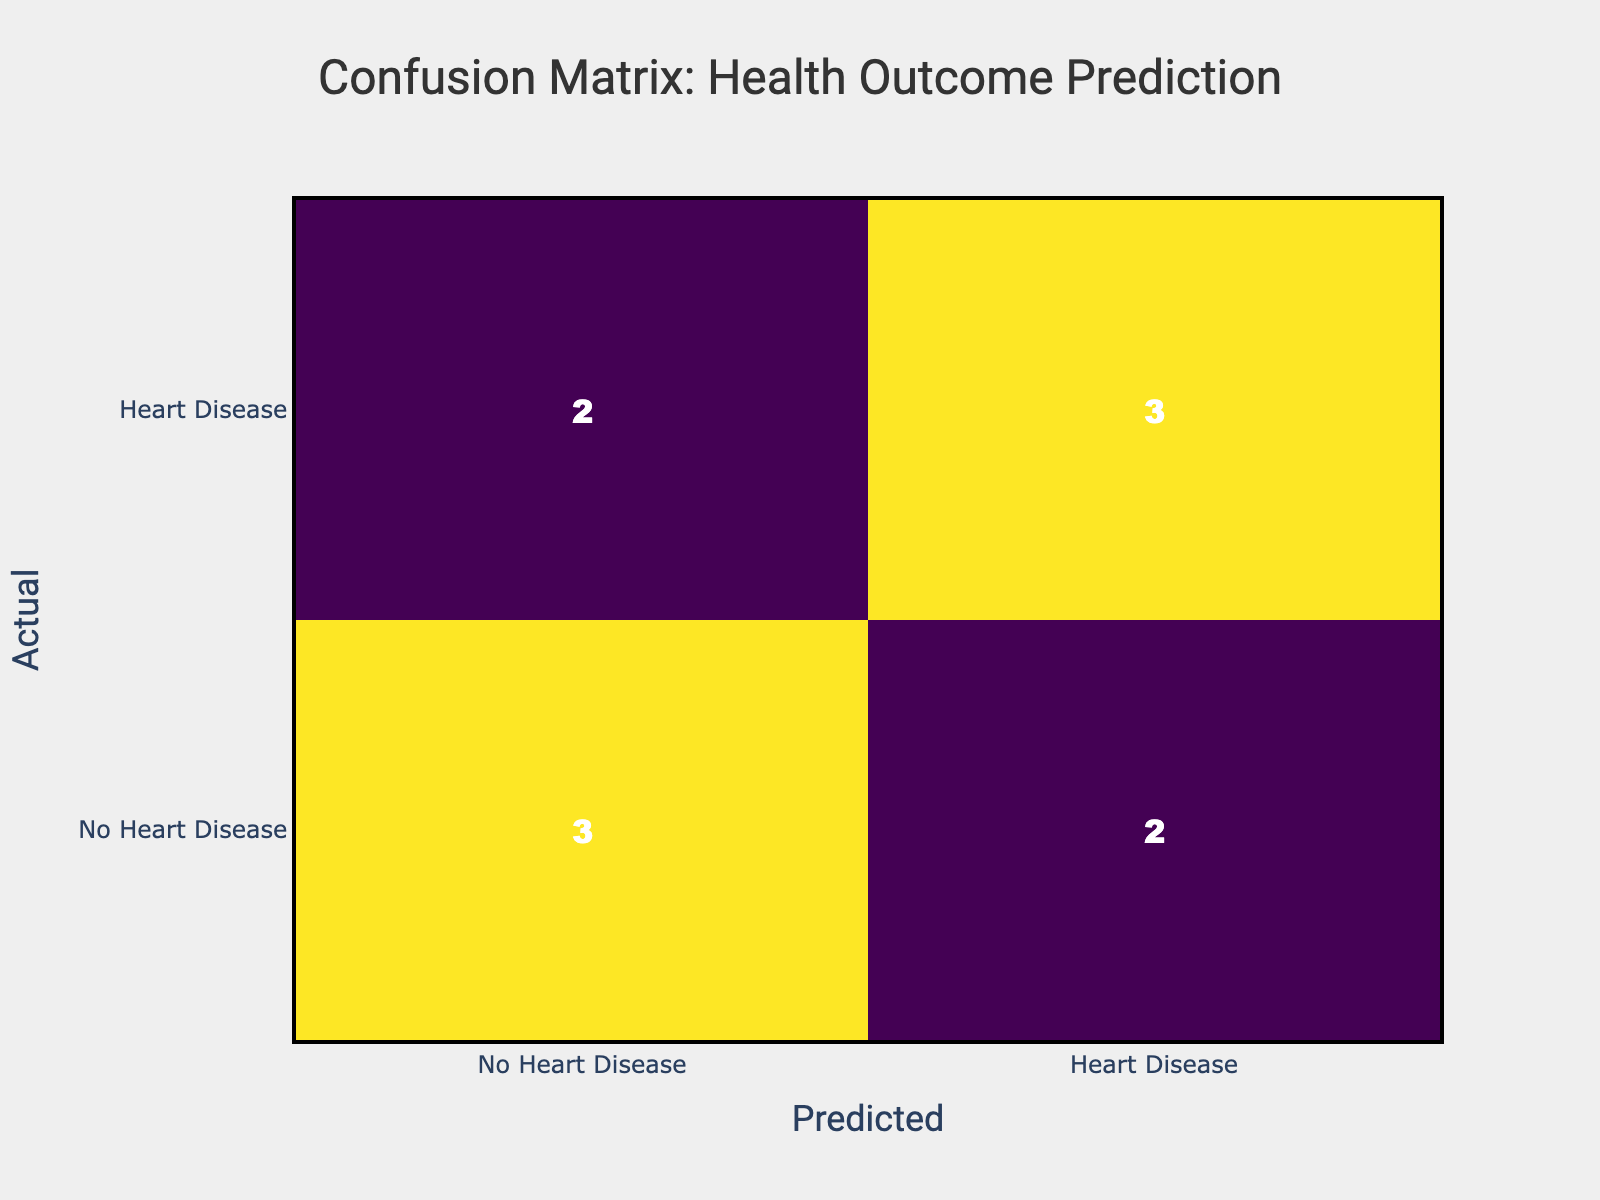What is the count of True Positives in the confusion matrix? The True Positives (TP) represent the cases that are correctly predicted as having Heart Disease. In the table, this corresponds to the entry where both the actual and predicted outcomes are "Heart Disease." Looking at the matrix, we find there are 3 instances of this (from rows: Smoking and Sedentary Lifestyle).
Answer: 3 What is the count of False Negatives in the confusion matrix? False Negatives (FN) are the cases that are incorrectly predicted as No Heart Disease when they actually have Heart Disease. This is found in the entry where the actual outcome is "Heart Disease," and the predicted outcome is "No Heart Disease." In this table, there is 1 instance of this (from the Poor Diet row).
Answer: 1 How many cases were predicted as No Heart Disease? To find the number of cases predicted as No Heart Disease, we sum the values in the predicted column labeled as "No Heart Disease." This involves adding the counts from the rows where the predicted outcome is "No Heart Disease," giving us 4 instances (Regular Exercise with No Heart Disease, Sedentary Lifestyle with No Heart Disease, Moderate Alcohol Intake with No Heart Disease, and Poor Diet incorrectly predicted as No Heart Disease).
Answer: 4 Is it true that all instances of Regular Exercise led to the prediction of No Heart Disease? To determine this, we examine the Data for Regular Exercise. There are two instances: one predicted as No Heart Disease and another as Heart Disease. Since one instance does not confirm the statement, it is false.
Answer: No What is the total count of samples in the confusion matrix? The total count of samples is the sum of all entries in the confusion matrix. Adding these values together, we find 10 (4 + 3 + 1 + 2 = 10).
Answer: 10 What percentage of actual Heart Disease cases were correctly predicted? To find this, we need to identify the True Positives (TP) and the total actual cases of Heart Disease (which is 4). We already established that TP is 3. The percentage is then calculated as (TP / Actual Heart Disease cases) * 100 = (3 / 4) * 100 = 75%.
Answer: 75% How many actual No Heart Disease cases were misclassified as Heart Disease? To find this, we look for False Positives (FP), which are predicted as Heart Disease but are actually No Heart Disease. In this table, there are 2 instances (from the Smoking and Moderate Alcohol Intake rows).
Answer: 2 What is the ratio of True Negatives to the total cases in the confusion matrix? True Negatives (TN) are cases that are correctly predicted as No Heart Disease, which corresponds to the entry in the confusion matrix with both actual and predicted outcomes as No Heart Disease. Here, TN is 4. The total cases are 10. Thus, the ratio is TN / Total Cases = 4 / 10 = 0.4.
Answer: 0.4 